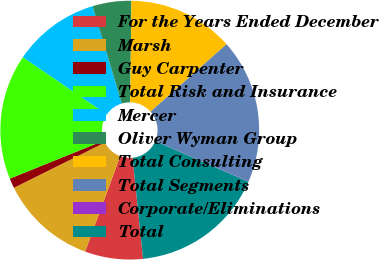Convert chart. <chart><loc_0><loc_0><loc_500><loc_500><pie_chart><fcel>For the Years Ended December<fcel>Marsh<fcel>Guy Carpenter<fcel>Total Risk and Insurance<fcel>Mercer<fcel>Oliver Wyman Group<fcel>Total Consulting<fcel>Total Segments<fcel>Corporate/Eliminations<fcel>Total<nl><fcel>7.24%<fcel>12.04%<fcel>1.24%<fcel>15.64%<fcel>10.84%<fcel>4.84%<fcel>13.24%<fcel>18.04%<fcel>0.04%<fcel>16.84%<nl></chart> 